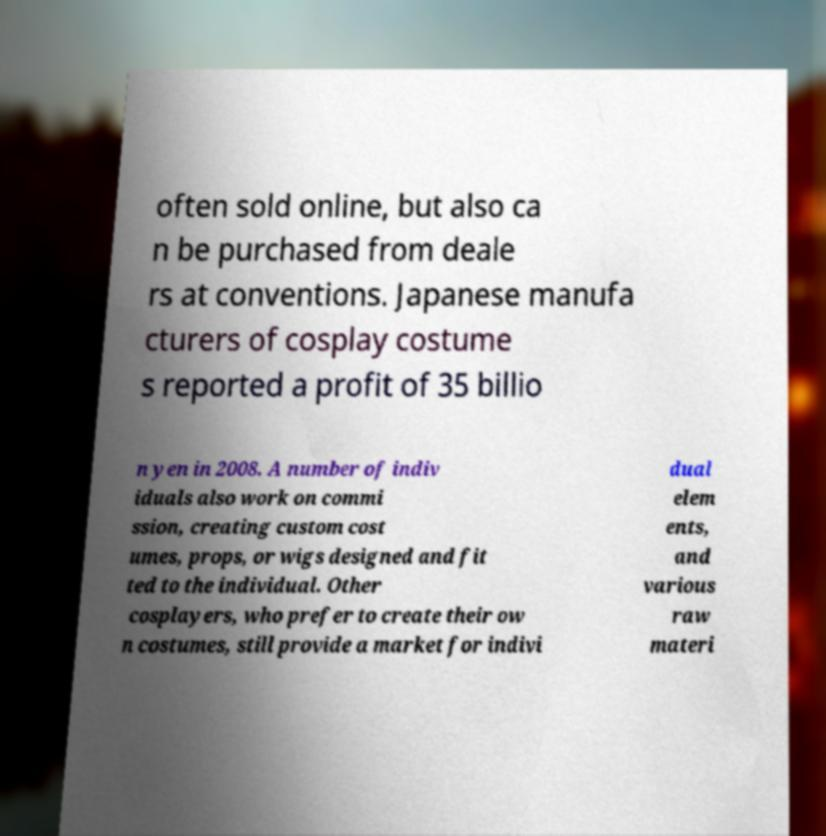Could you extract and type out the text from this image? often sold online, but also ca n be purchased from deale rs at conventions. Japanese manufa cturers of cosplay costume s reported a profit of 35 billio n yen in 2008. A number of indiv iduals also work on commi ssion, creating custom cost umes, props, or wigs designed and fit ted to the individual. Other cosplayers, who prefer to create their ow n costumes, still provide a market for indivi dual elem ents, and various raw materi 